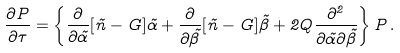Convert formula to latex. <formula><loc_0><loc_0><loc_500><loc_500>\frac { \partial P } { \partial \tau } = \left \{ \frac { \partial } { \partial \tilde { \alpha } } [ \tilde { n } - G ] \tilde { \alpha } + \frac { \partial } { \partial \tilde { \beta } } [ \tilde { n } - G ] \tilde { \beta } + 2 Q \frac { \partial ^ { 2 } } { \partial \tilde { \alpha } \partial \tilde { \beta } } \right \} P \, .</formula> 